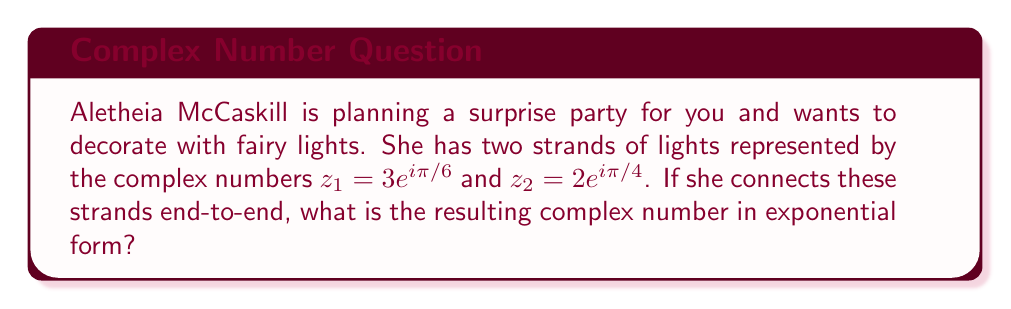Show me your answer to this math problem. To solve this problem, we need to multiply the two complex numbers in exponential form. When multiplying complex numbers in exponential form, we multiply the magnitudes and add the angles.

Let's break it down step by step:

1) For $z_1 = 3e^{i\pi/6}$:
   Magnitude: $|z_1| = 3$
   Angle: $\theta_1 = \pi/6$

2) For $z_2 = 2e^{i\pi/4}$:
   Magnitude: $|z_2| = 2$
   Angle: $\theta_2 = \pi/4$

3) Multiply the magnitudes:
   $|z_1| \cdot |z_2| = 3 \cdot 2 = 6$

4) Add the angles:
   $\theta_1 + \theta_2 = \pi/6 + \pi/4 = \pi/6 + 3\pi/12 = 5\pi/12$

5) The resulting complex number in exponential form is:
   $z = 6e^{i5\pi/12}$

This represents the combined length and orientation of the two strands of fairy lights when connected end-to-end.
Answer: $6e^{i5\pi/12}$ 